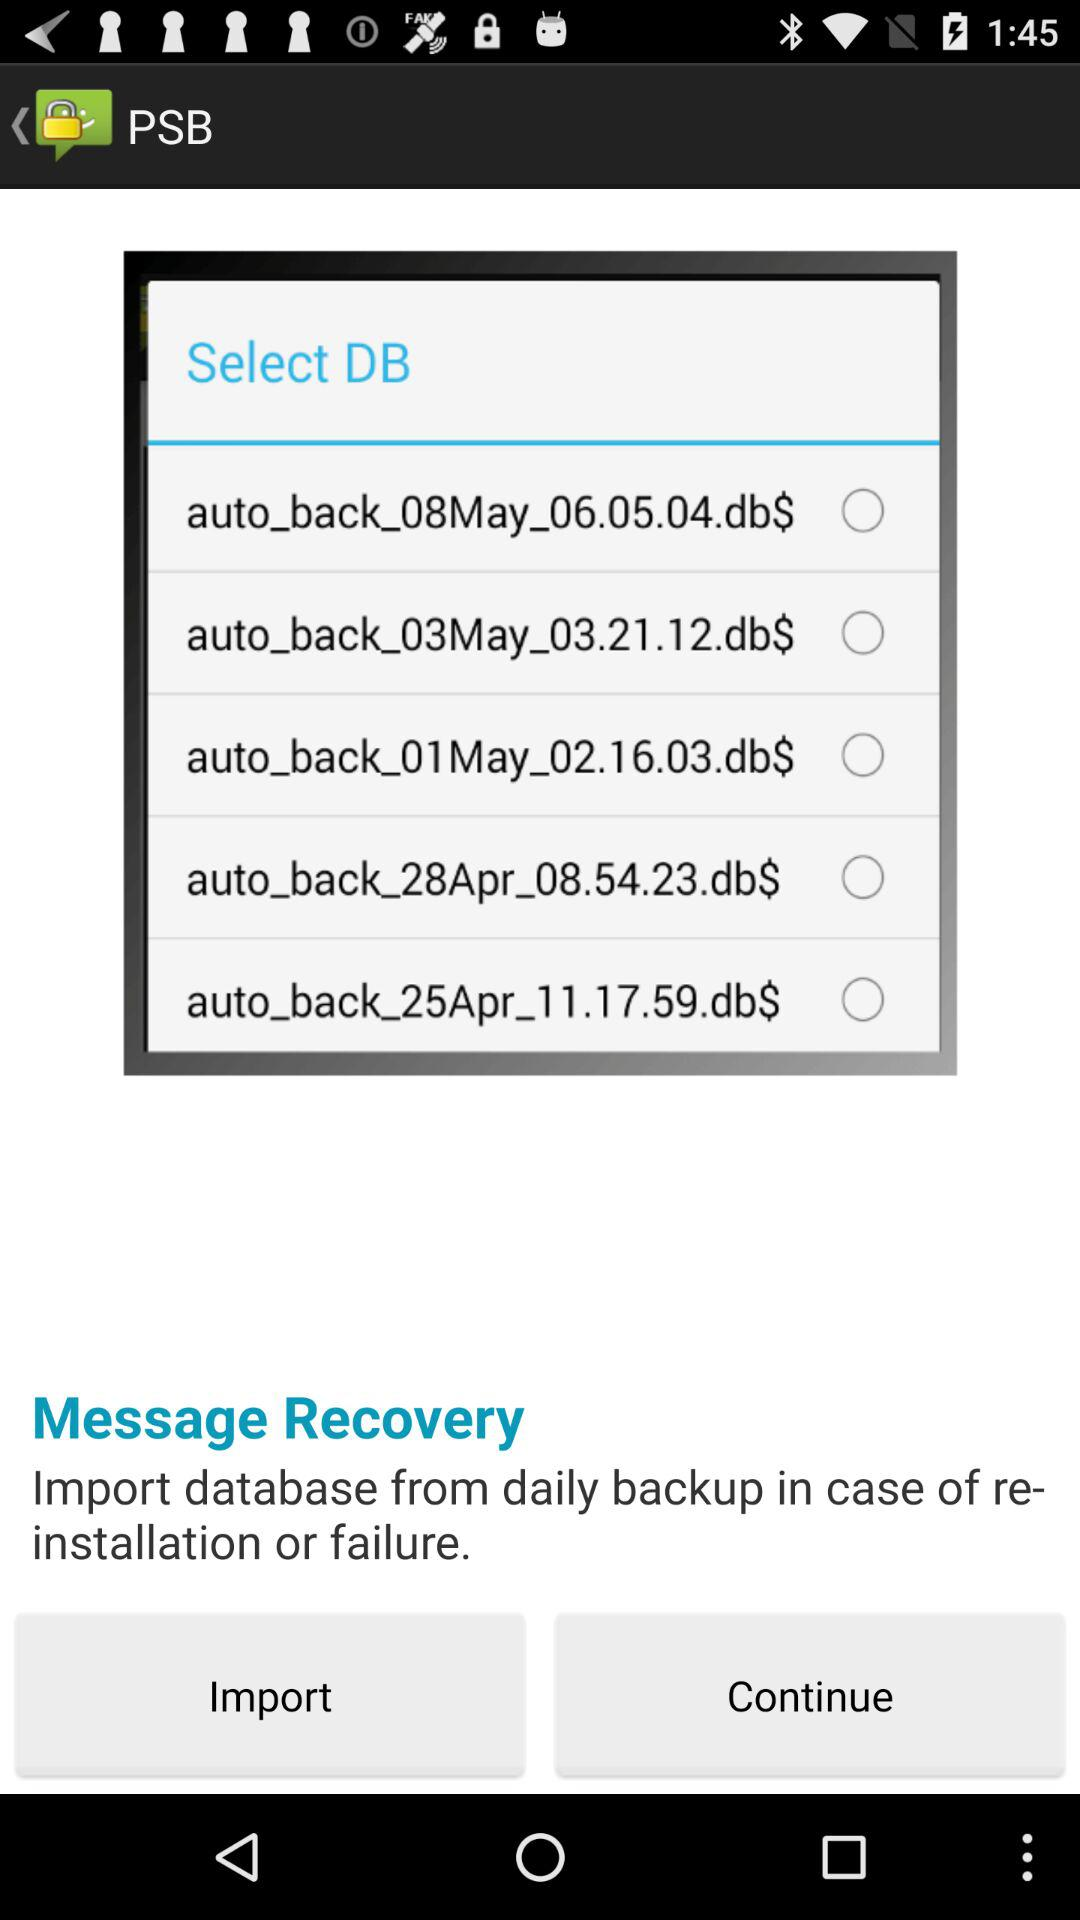How many days are represented by the available backup files? The available backup files represent 5 different days. The dates indicated in the filenames suggest that each file corresponds to a separate day's backup, providing a range of options for message recovery. 